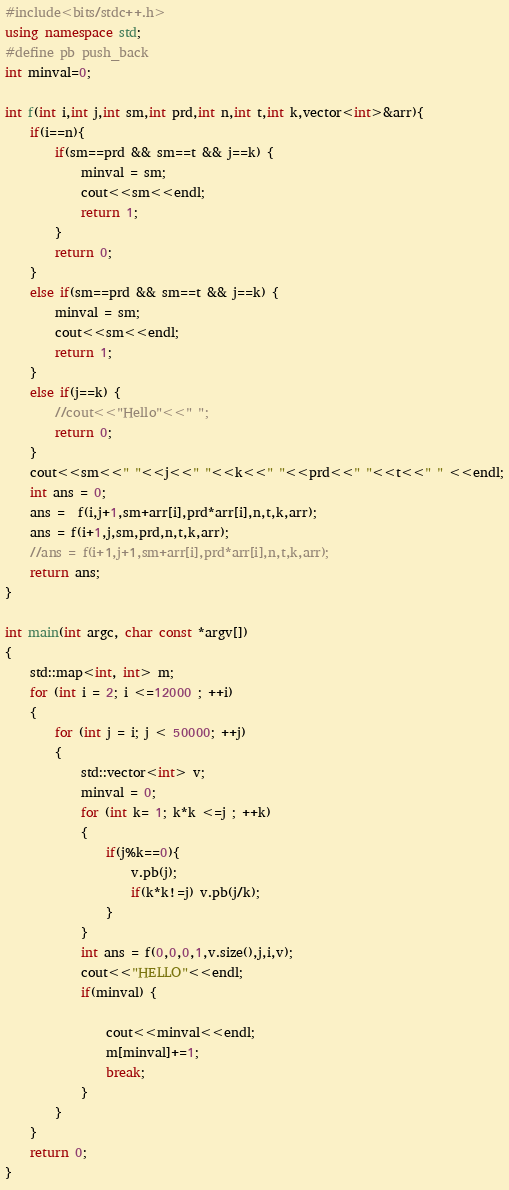Convert code to text. <code><loc_0><loc_0><loc_500><loc_500><_C++_>#include<bits/stdc++.h>
using namespace std;
#define pb push_back
int minval=0;

int f(int i,int j,int sm,int prd,int n,int t,int k,vector<int>&arr){
	if(i==n){
		if(sm==prd && sm==t && j==k) {
			minval = sm;
			cout<<sm<<endl;
			return 1;
		}
		return 0;
	}
	else if(sm==prd && sm==t && j==k) {
		minval = sm;
		cout<<sm<<endl;
		return 1;
	}
	else if(j==k) {
		//cout<<"Hello"<<" ";
		return 0;
	}
	cout<<sm<<" "<<j<<" "<<k<<" "<<prd<<" "<<t<<" " <<endl;
	int ans = 0;
	ans =  f(i,j+1,sm+arr[i],prd*arr[i],n,t,k,arr);
	ans = f(i+1,j,sm,prd,n,t,k,arr);
	//ans = f(i+1,j+1,sm+arr[i],prd*arr[i],n,t,k,arr);
	return ans;
}

int main(int argc, char const *argv[])
{
	std::map<int, int> m;
	for (int i = 2; i <=12000 ; ++i)
	{
		for (int j = i; j < 50000; ++j)
		{
			std::vector<int> v;
			minval = 0;
			for (int k= 1; k*k <=j ; ++k)
			{
				if(j%k==0){
					v.pb(j);
					if(k*k!=j) v.pb(j/k);
				}
			}
			int ans = f(0,0,0,1,v.size(),j,i,v);
			cout<<"HELLO"<<endl;
			if(minval) {

				cout<<minval<<endl;
				m[minval]+=1;
				break;
			}
		}
	}
	return 0;
}</code> 